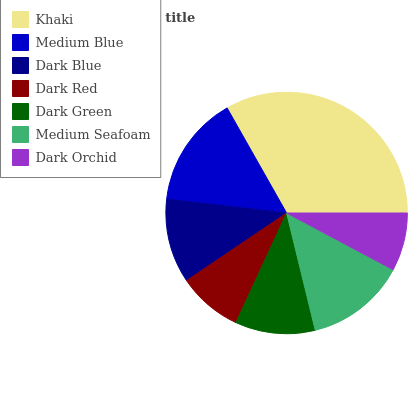Is Dark Orchid the minimum?
Answer yes or no. Yes. Is Khaki the maximum?
Answer yes or no. Yes. Is Medium Blue the minimum?
Answer yes or no. No. Is Medium Blue the maximum?
Answer yes or no. No. Is Khaki greater than Medium Blue?
Answer yes or no. Yes. Is Medium Blue less than Khaki?
Answer yes or no. Yes. Is Medium Blue greater than Khaki?
Answer yes or no. No. Is Khaki less than Medium Blue?
Answer yes or no. No. Is Dark Blue the high median?
Answer yes or no. Yes. Is Dark Blue the low median?
Answer yes or no. Yes. Is Dark Red the high median?
Answer yes or no. No. Is Medium Seafoam the low median?
Answer yes or no. No. 